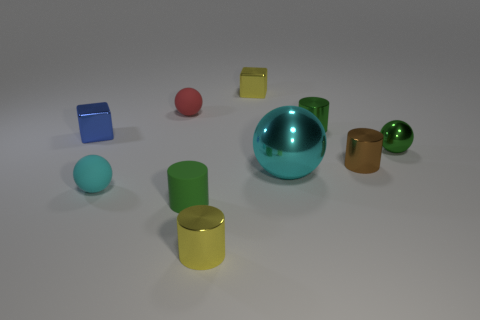Subtract all cyan matte balls. How many balls are left? 3 Subtract all brown cylinders. How many cylinders are left? 3 Subtract 1 cylinders. How many cylinders are left? 3 Subtract all red cylinders. How many red balls are left? 1 Subtract all spheres. How many objects are left? 6 Subtract all blue cylinders. Subtract all gray spheres. How many cylinders are left? 4 Subtract all small green metallic cylinders. Subtract all small shiny cylinders. How many objects are left? 6 Add 9 brown cylinders. How many brown cylinders are left? 10 Add 8 purple matte spheres. How many purple matte spheres exist? 8 Subtract 1 yellow blocks. How many objects are left? 9 